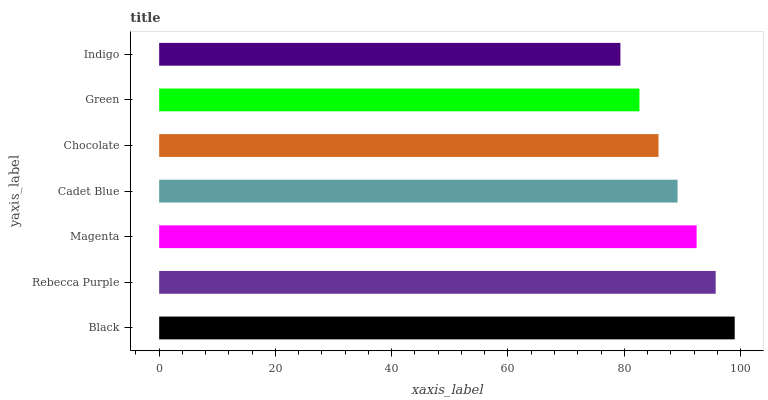Is Indigo the minimum?
Answer yes or no. Yes. Is Black the maximum?
Answer yes or no. Yes. Is Rebecca Purple the minimum?
Answer yes or no. No. Is Rebecca Purple the maximum?
Answer yes or no. No. Is Black greater than Rebecca Purple?
Answer yes or no. Yes. Is Rebecca Purple less than Black?
Answer yes or no. Yes. Is Rebecca Purple greater than Black?
Answer yes or no. No. Is Black less than Rebecca Purple?
Answer yes or no. No. Is Cadet Blue the high median?
Answer yes or no. Yes. Is Cadet Blue the low median?
Answer yes or no. Yes. Is Rebecca Purple the high median?
Answer yes or no. No. Is Black the low median?
Answer yes or no. No. 